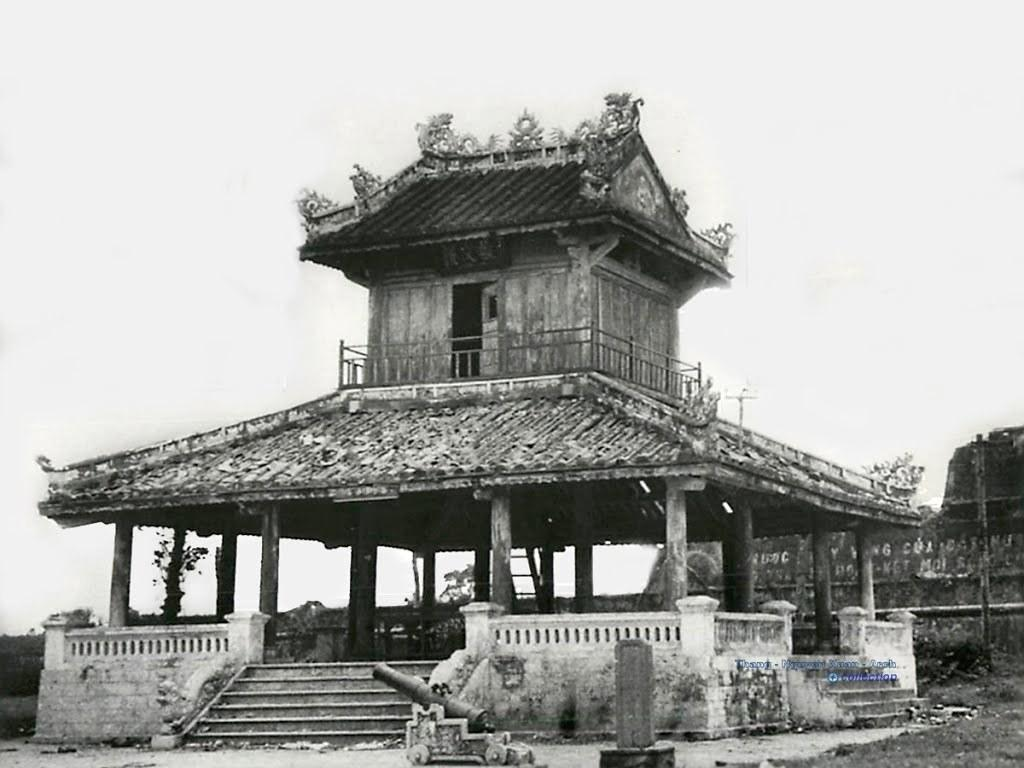What is the color scheme of the image? The image is black and white. What architectural feature can be seen in the image? There are steps in the image. What type of barrier is present in the image? There is fencing in the image. What type of structure is visible in the image? There is a shed in the image. What part of the natural environment is visible in the image? The sky is visible behind the shed. How many servants are visible in the image? There are no servants present in the image. What type of detail can be seen on the steps in the image? There is no specific detail mentioned on the steps in the provided facts, so it cannot be determined from the image. 